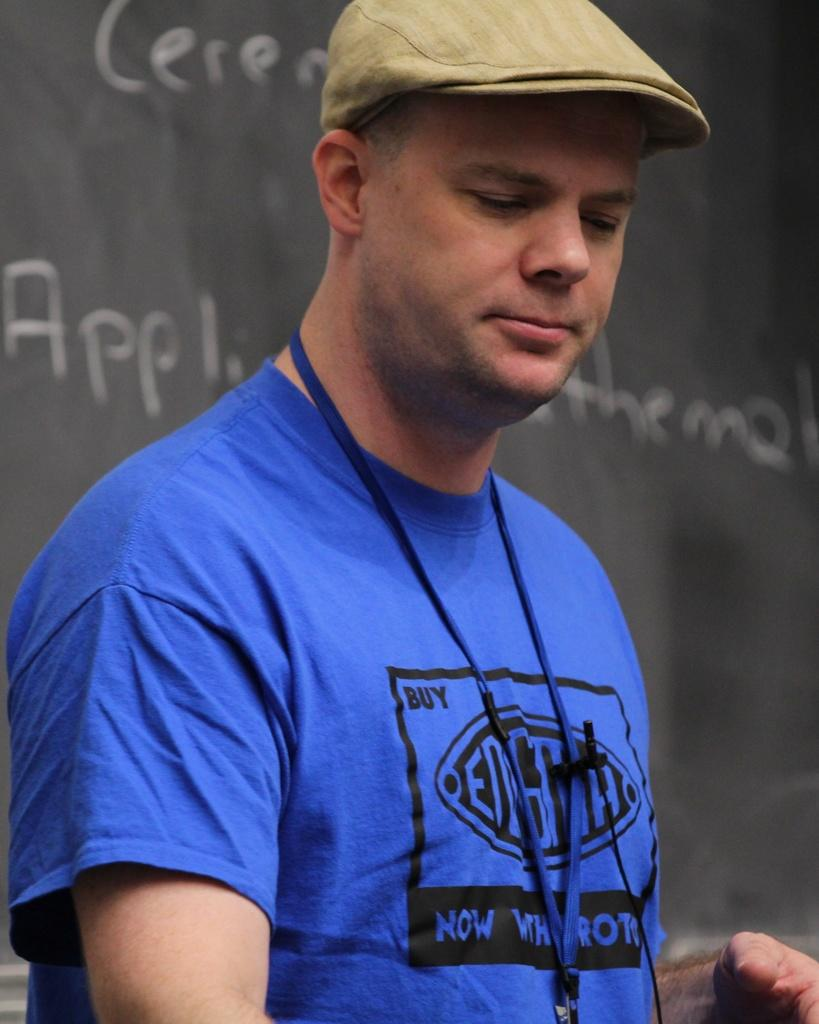<image>
Render a clear and concise summary of the photo. A man wearing a shirt that says Buy and Now on the front stands in front of a chalkboard. 